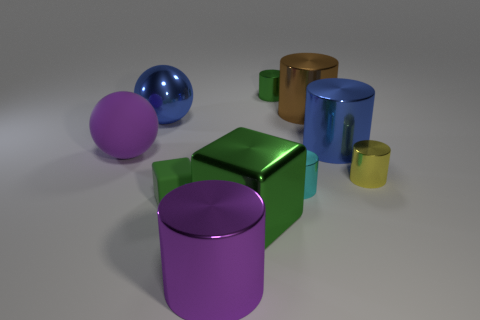Subtract all blue cylinders. How many cylinders are left? 5 Subtract all cyan cylinders. How many cylinders are left? 5 Subtract all brown cylinders. Subtract all cyan blocks. How many cylinders are left? 5 Subtract all cylinders. How many objects are left? 4 Add 8 tiny yellow things. How many tiny yellow things exist? 9 Subtract 0 brown cubes. How many objects are left? 10 Subtract all small green objects. Subtract all red matte things. How many objects are left? 8 Add 7 large brown cylinders. How many large brown cylinders are left? 8 